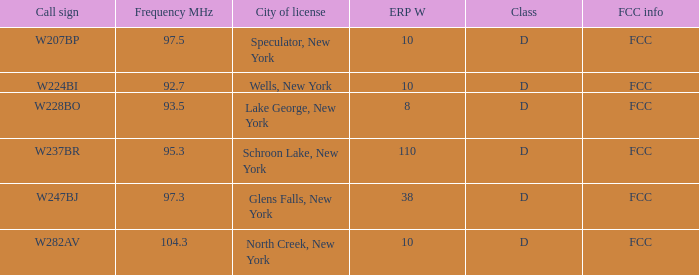Identify the erp w with a 9 10.0. 